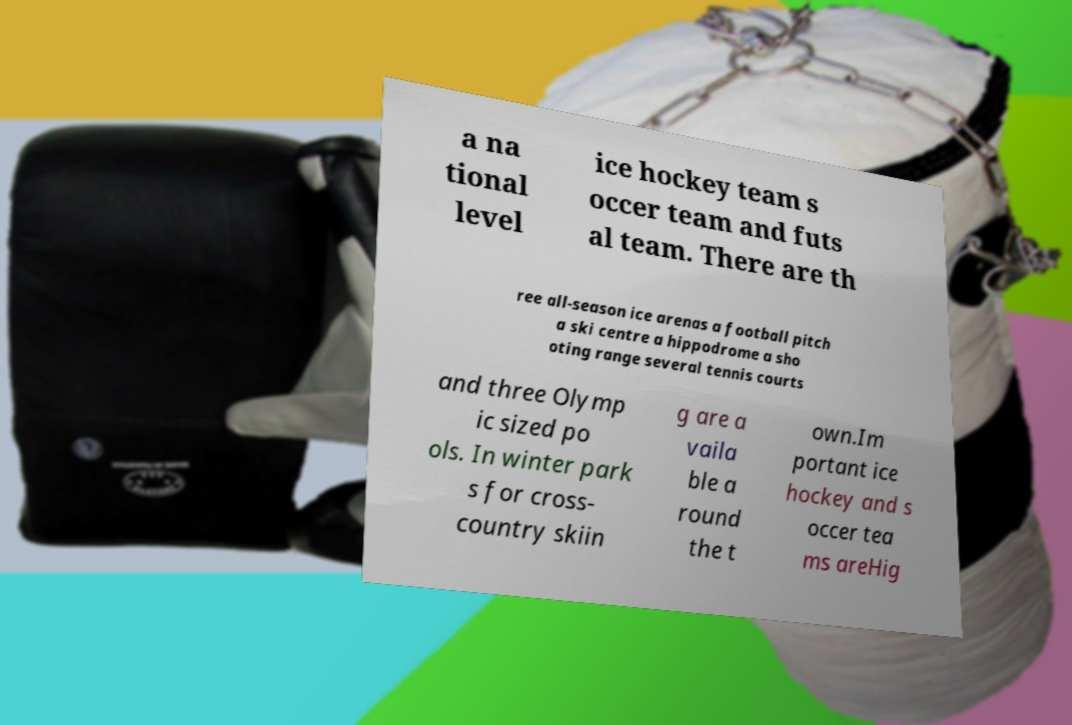Could you assist in decoding the text presented in this image and type it out clearly? a na tional level ice hockey team s occer team and futs al team. There are th ree all-season ice arenas a football pitch a ski centre a hippodrome a sho oting range several tennis courts and three Olymp ic sized po ols. In winter park s for cross- country skiin g are a vaila ble a round the t own.Im portant ice hockey and s occer tea ms areHig 